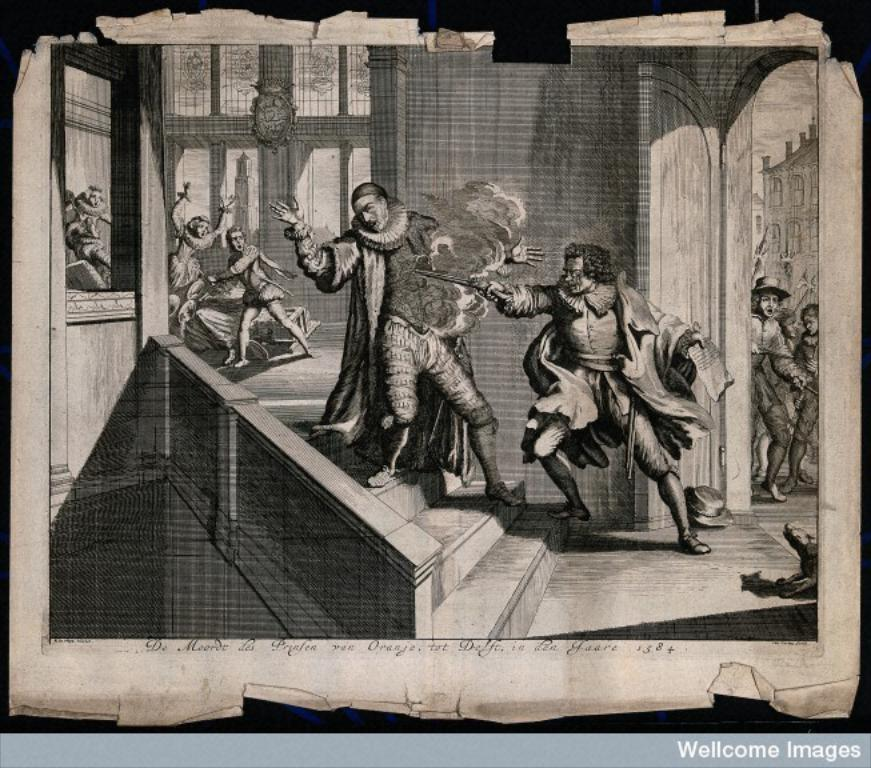What type of picture is the image? The image is an edited picture. What color scheme is used in the image? The image appears to be an old black and white picture. What is happening in the animated images in the picture? The animated images depict a war going on in a palace. What type of appliance can be seen in the image? There is no appliance present in the image; it features animated images of a war in a palace. What time of day is it in the image? The image is an old black and white picture, so it is not possible to determine the time of day from the image. 